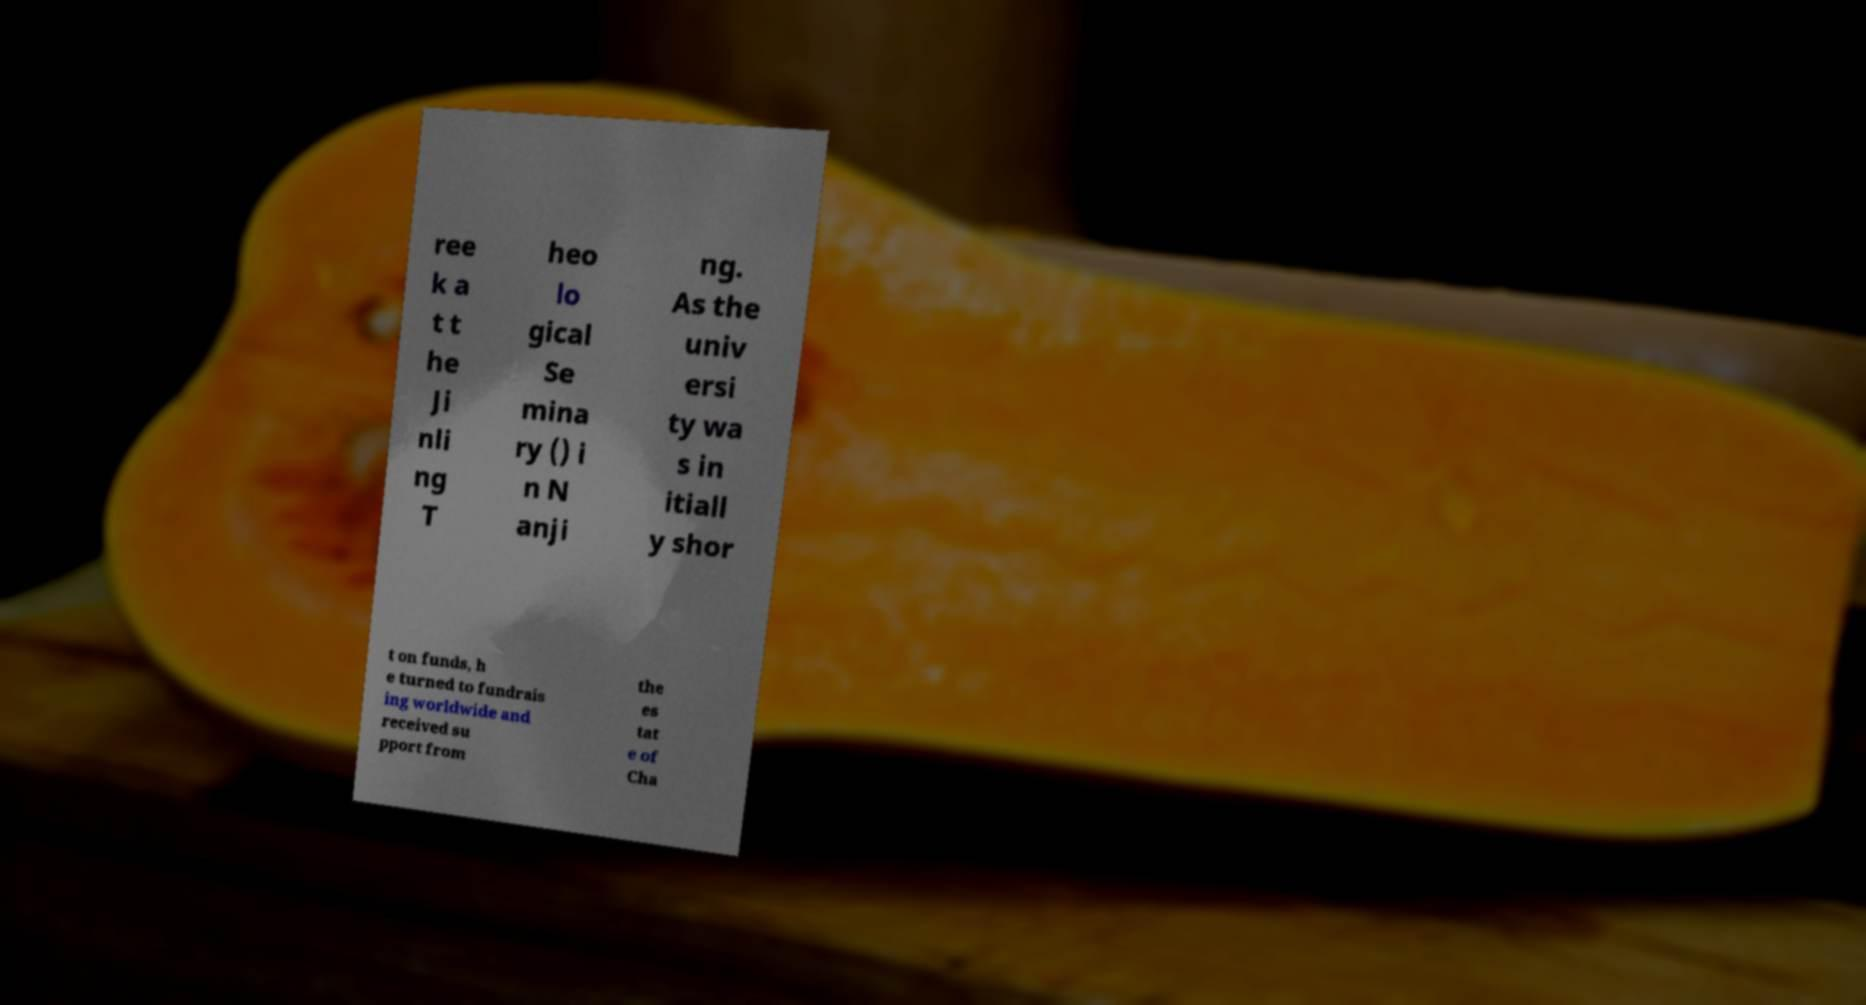For documentation purposes, I need the text within this image transcribed. Could you provide that? ree k a t t he Ji nli ng T heo lo gical Se mina ry () i n N anji ng. As the univ ersi ty wa s in itiall y shor t on funds, h e turned to fundrais ing worldwide and received su pport from the es tat e of Cha 